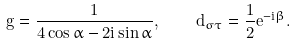<formula> <loc_0><loc_0><loc_500><loc_500>g = \frac { 1 } { 4 \cos \alpha - 2 i \sin \alpha } , \quad d _ { \sigma \tau } = \frac { 1 } { 2 } e ^ { - i \beta } .</formula> 